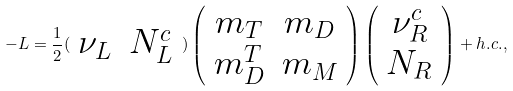<formula> <loc_0><loc_0><loc_500><loc_500>- L = \frac { 1 } { 2 } ( \begin{array} { c c } \nu _ { L } & N ^ { c } _ { L } \end{array} ) \left ( \begin{array} { c c } m _ { T } & m _ { D } \\ m _ { D } ^ { T } & m _ { M } \end{array} \right ) \left ( \begin{array} { c } \nu ^ { c } _ { R } \\ N _ { R } \end{array} \right ) + h . c . ,</formula> 